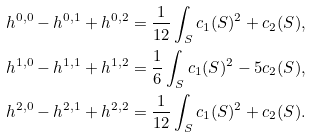<formula> <loc_0><loc_0><loc_500><loc_500>h ^ { 0 , 0 } - h ^ { 0 , 1 } + h ^ { 0 , 2 } & = \frac { 1 } { 1 2 } \int _ { S } c _ { 1 } ( S ) ^ { 2 } + c _ { 2 } ( S ) , \\ h ^ { 1 , 0 } - h ^ { 1 , 1 } + h ^ { 1 , 2 } & = \frac { 1 } { 6 } \int _ { S } c _ { 1 } ( S ) ^ { 2 } - 5 c _ { 2 } ( S ) , \\ h ^ { 2 , 0 } - h ^ { 2 , 1 } + h ^ { 2 , 2 } & = \frac { 1 } { 1 2 } \int _ { S } c _ { 1 } ( S ) ^ { 2 } + c _ { 2 } ( S ) .</formula> 